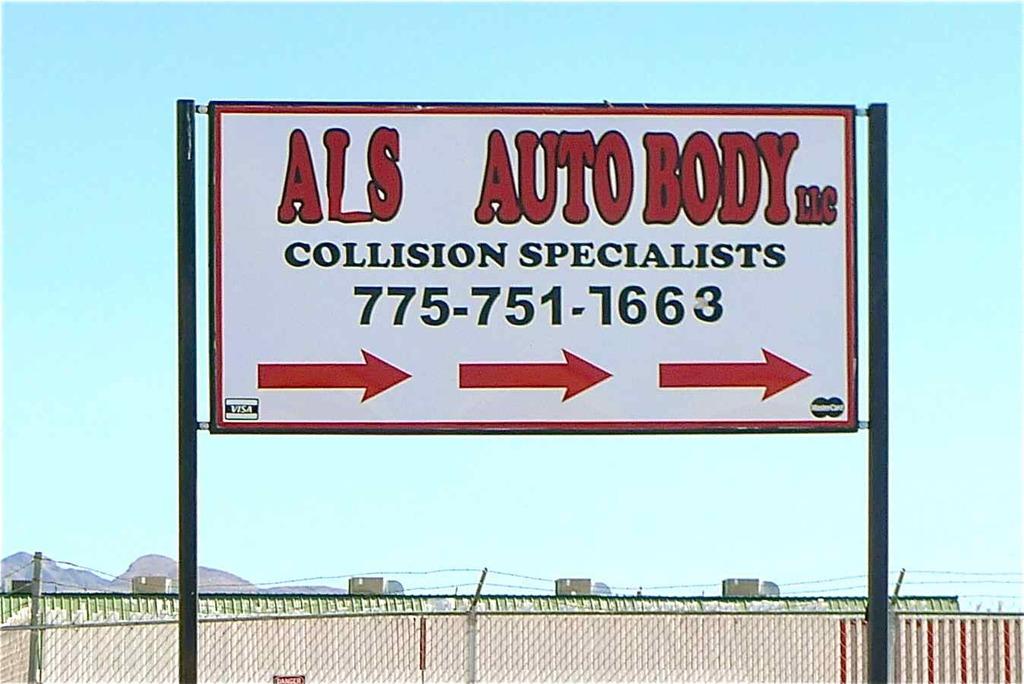What is the phone number of als auto body?
Provide a short and direct response. 775-751-1663. What type of company is als auto body?
Give a very brief answer. Collision specialists. 